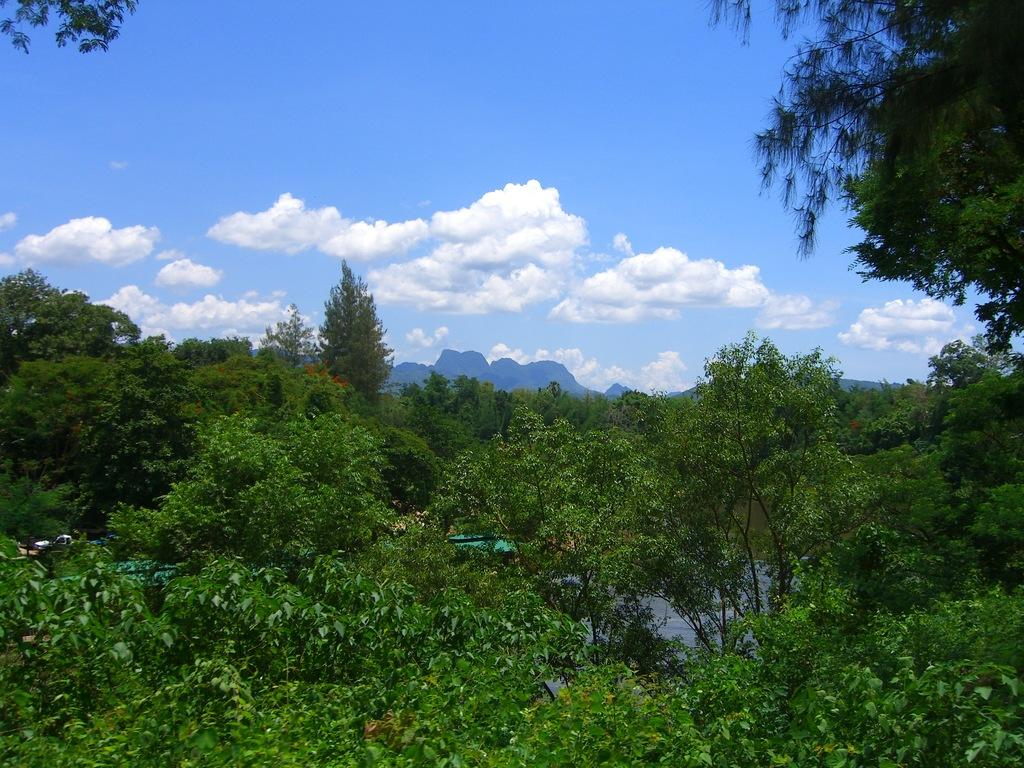What type of natural elements can be seen in the image? There are trees in the image. How would you describe the sky in the image? The sky is blue and cloudy. Can you identify any man-made objects in motion in the image? Yes, there is a vehicle moving in the image. What type of notebook is being used by the yak in the image? There is no yak or notebook present in the image. 